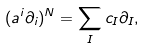Convert formula to latex. <formula><loc_0><loc_0><loc_500><loc_500>( a ^ { i } \partial _ { i } ) ^ { N } = \sum _ { I } c _ { I } \partial _ { I } ,</formula> 